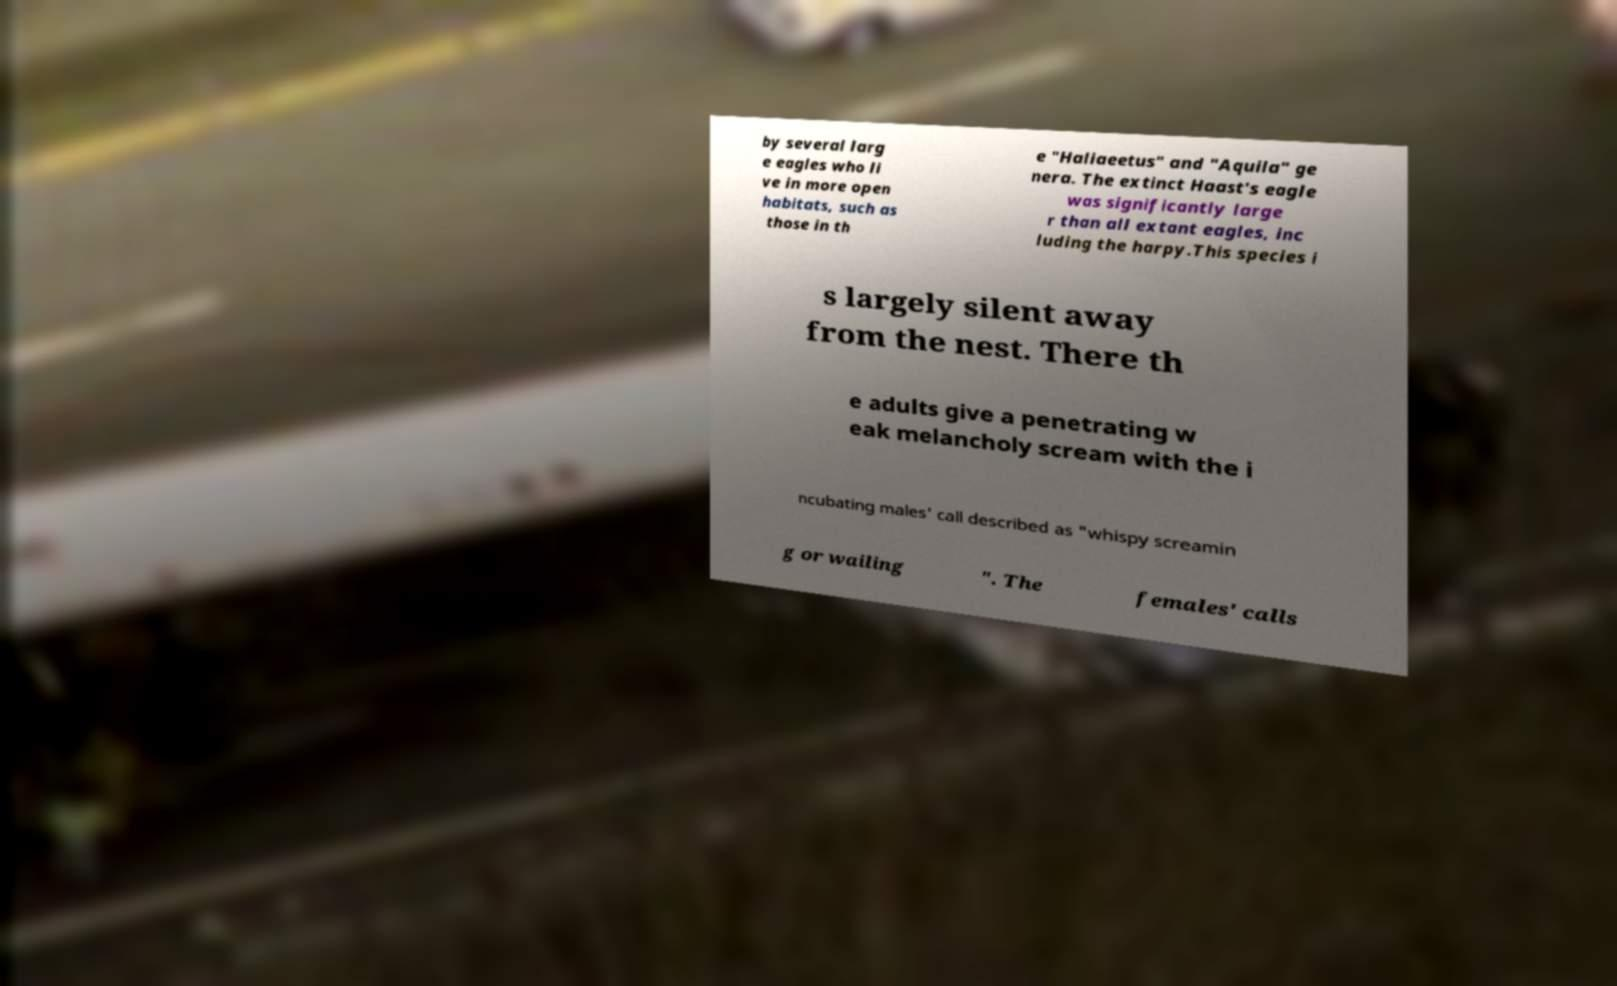Please identify and transcribe the text found in this image. by several larg e eagles who li ve in more open habitats, such as those in th e "Haliaeetus" and "Aquila" ge nera. The extinct Haast's eagle was significantly large r than all extant eagles, inc luding the harpy.This species i s largely silent away from the nest. There th e adults give a penetrating w eak melancholy scream with the i ncubating males' call described as "whispy screamin g or wailing ". The females' calls 